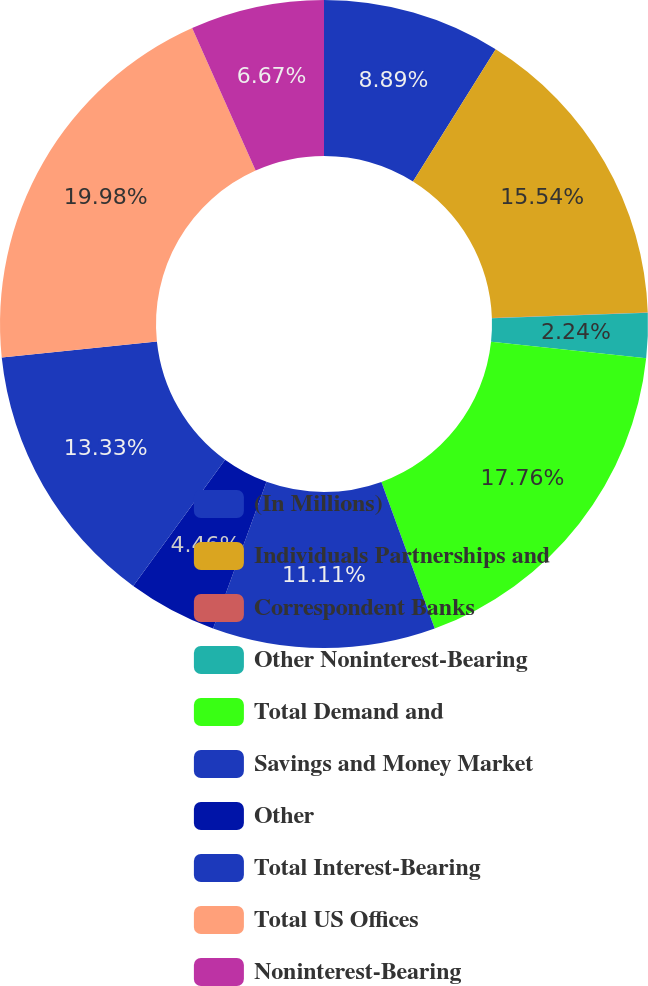Convert chart to OTSL. <chart><loc_0><loc_0><loc_500><loc_500><pie_chart><fcel>(In Millions)<fcel>Individuals Partnerships and<fcel>Correspondent Banks<fcel>Other Noninterest-Bearing<fcel>Total Demand and<fcel>Savings and Money Market<fcel>Other<fcel>Total Interest-Bearing<fcel>Total US Offices<fcel>Noninterest-Bearing<nl><fcel>8.89%<fcel>15.54%<fcel>0.02%<fcel>2.24%<fcel>17.76%<fcel>11.11%<fcel>4.46%<fcel>13.33%<fcel>19.98%<fcel>6.67%<nl></chart> 